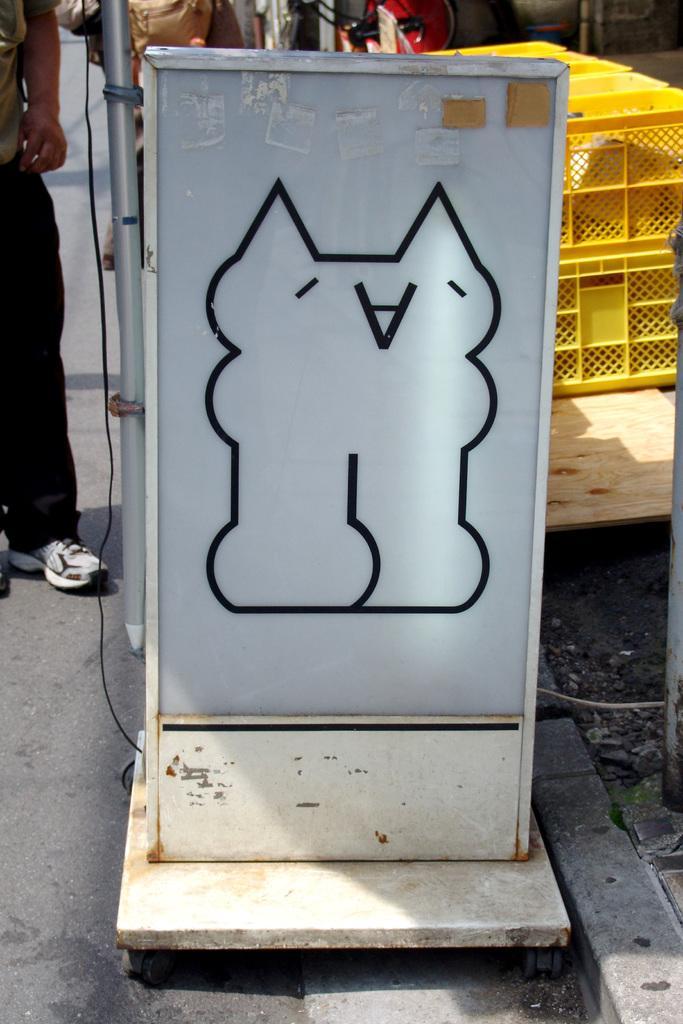How would you summarize this image in a sentence or two? In this picture there is a white color board poster. Behind there is a yellow color basket and on the left side there is man standing near the board poster. 